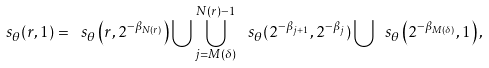<formula> <loc_0><loc_0><loc_500><loc_500>\ s _ { \theta } ( r , 1 ) = \ s _ { \theta } \left ( r , 2 ^ { - \beta _ { N ( r ) } } \right ) \bigcup \bigcup _ { j = M ( \delta ) } ^ { N ( r ) - 1 } \, \ s _ { \theta } ( 2 ^ { - \beta _ { j + 1 } } , 2 ^ { - \beta _ { j } } ) \bigcup \ s _ { \theta } \left ( 2 ^ { - \beta _ { M ( \delta ) } } , 1 \right ) ,</formula> 